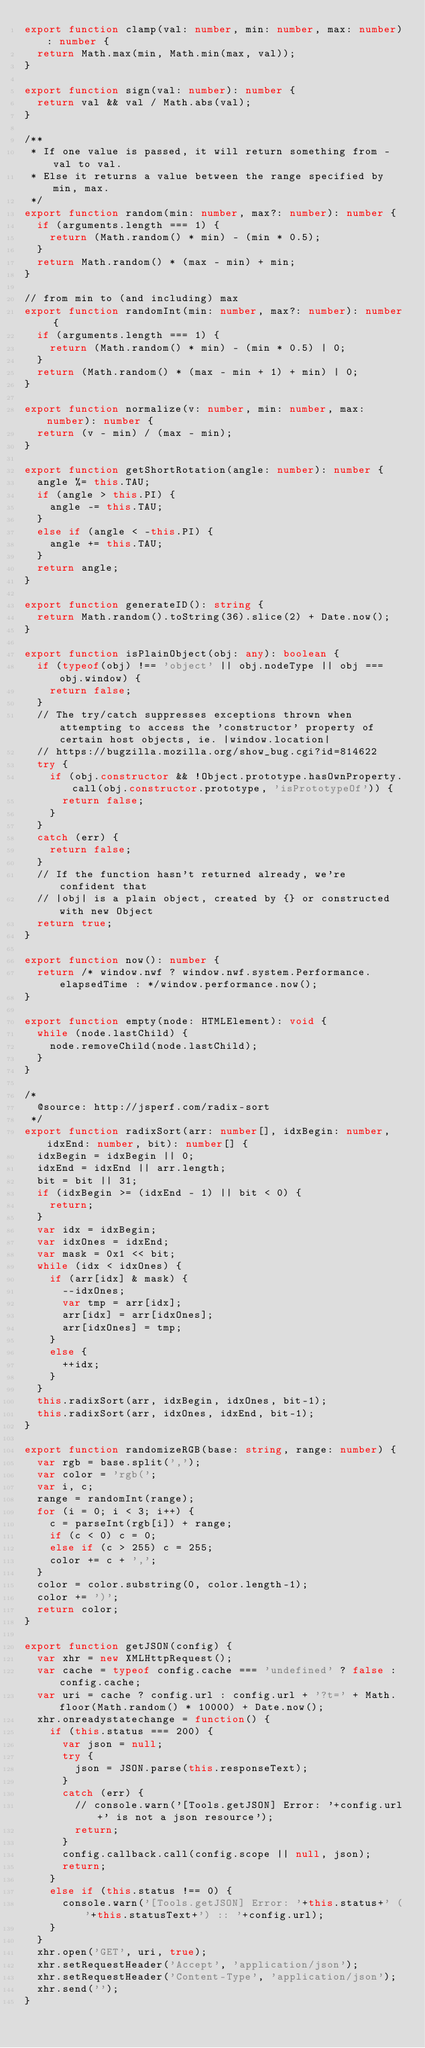Convert code to text. <code><loc_0><loc_0><loc_500><loc_500><_TypeScript_>export function clamp(val: number, min: number, max: number): number {
	return Math.max(min, Math.min(max, val));
}

export function sign(val: number): number {
	return val && val / Math.abs(val);
}

/**
 * If one value is passed, it will return something from -val to val.
 * Else it returns a value between the range specified by min, max.
 */
export function random(min: number, max?: number): number {
	if (arguments.length === 1) {
		return (Math.random() * min) - (min * 0.5);
	}
	return Math.random() * (max - min) + min;
}

// from min to (and including) max
export function randomInt(min: number, max?: number): number {
	if (arguments.length === 1) {
		return (Math.random() * min) - (min * 0.5) | 0;
	}
	return (Math.random() * (max - min + 1) + min) | 0;
}

export function normalize(v: number, min: number, max: number): number {
	return (v - min) / (max - min);
}

export function getShortRotation(angle: number): number {
	angle %= this.TAU;
	if (angle > this.PI) {
		angle -= this.TAU;
	}
	else if (angle < -this.PI) {
		angle += this.TAU;
	}
	return angle;
}

export function generateID(): string {
	return Math.random().toString(36).slice(2) + Date.now();
}

export function isPlainObject(obj: any): boolean {
	if (typeof(obj) !== 'object' || obj.nodeType || obj === obj.window) {
		return false;
	}
	// The try/catch suppresses exceptions thrown when attempting to access the 'constructor' property of certain host objects, ie. |window.location|
	// https://bugzilla.mozilla.org/show_bug.cgi?id=814622
	try {
		if (obj.constructor && !Object.prototype.hasOwnProperty.call(obj.constructor.prototype, 'isPrototypeOf')) {
			return false;
		}
	}
	catch (err) {
		return false;
	}
	// If the function hasn't returned already, we're confident that
	// |obj| is a plain object, created by {} or constructed with new Object
	return true;
}

export function now(): number {
	return /* window.nwf ? window.nwf.system.Performance.elapsedTime : */window.performance.now();
}

export function empty(node: HTMLElement): void {
	while (node.lastChild) {
		node.removeChild(node.lastChild);
	}
}

/*
	@source: http://jsperf.com/radix-sort
 */
export function radixSort(arr: number[], idxBegin: number, idxEnd: number, bit): number[] {
	idxBegin = idxBegin || 0;
	idxEnd = idxEnd || arr.length;
	bit = bit || 31;
	if (idxBegin >= (idxEnd - 1) || bit < 0) {
		return;
	}
	var idx = idxBegin;
	var idxOnes = idxEnd;
	var mask = 0x1 << bit;
	while (idx < idxOnes) {
		if (arr[idx] & mask) {
			--idxOnes;
			var tmp = arr[idx];
			arr[idx] = arr[idxOnes];
			arr[idxOnes] = tmp;
		}
		else {
			++idx;
		}
	}
	this.radixSort(arr, idxBegin, idxOnes, bit-1);
	this.radixSort(arr, idxOnes, idxEnd, bit-1);
}

export function randomizeRGB(base: string, range: number) {
	var rgb = base.split(',');
	var color = 'rgb(';
	var i, c;
	range = randomInt(range);
	for (i = 0; i < 3; i++) {
		c = parseInt(rgb[i]) + range;
		if (c < 0) c = 0;
		else if (c > 255) c = 255;
		color += c + ',';
	}
	color = color.substring(0, color.length-1);
	color += ')';
	return color;
}

export function getJSON(config) {
	var xhr = new XMLHttpRequest();
	var cache = typeof config.cache === 'undefined' ? false : config.cache;
	var uri = cache ? config.url : config.url + '?t=' + Math.floor(Math.random() * 10000) + Date.now();
	xhr.onreadystatechange = function() {
		if (this.status === 200) {
			var json = null;
			try {
				json = JSON.parse(this.responseText);
			}
			catch (err) {
				// console.warn('[Tools.getJSON] Error: '+config.url+' is not a json resource');
				return;
			}
			config.callback.call(config.scope || null, json);
			return;
		}
		else if (this.status !== 0) {
			console.warn('[Tools.getJSON] Error: '+this.status+' ('+this.statusText+') :: '+config.url);
		}
	}
	xhr.open('GET', uri, true);
	xhr.setRequestHeader('Accept', 'application/json');
	xhr.setRequestHeader('Content-Type', 'application/json');
	xhr.send('');
}
</code> 